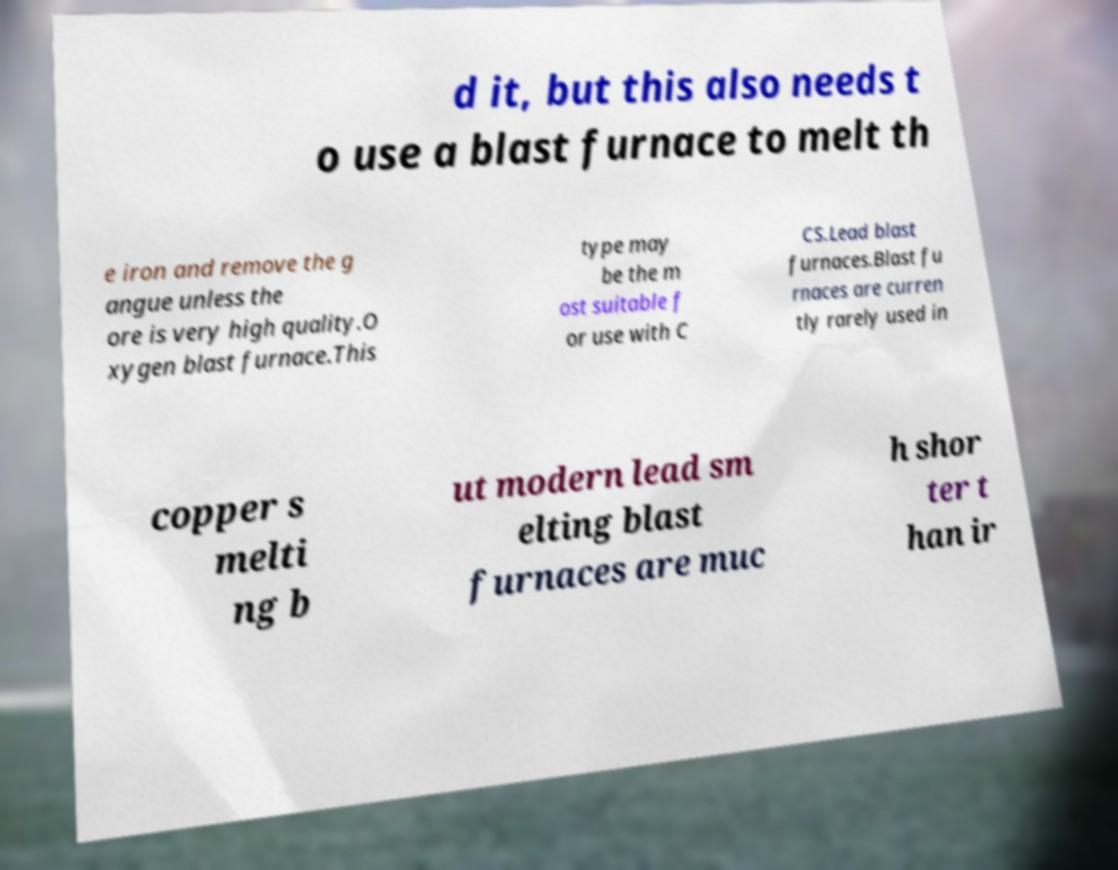What messages or text are displayed in this image? I need them in a readable, typed format. d it, but this also needs t o use a blast furnace to melt th e iron and remove the g angue unless the ore is very high quality.O xygen blast furnace.This type may be the m ost suitable f or use with C CS.Lead blast furnaces.Blast fu rnaces are curren tly rarely used in copper s melti ng b ut modern lead sm elting blast furnaces are muc h shor ter t han ir 